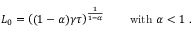<formula> <loc_0><loc_0><loc_500><loc_500>L _ { 0 } = \left ( ( 1 - \alpha ) \gamma \tau \right ) ^ { \frac { 1 } { 1 - \alpha } } \quad w i t h \ \alpha < 1 \ .</formula> 